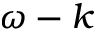Convert formula to latex. <formula><loc_0><loc_0><loc_500><loc_500>\omega - k</formula> 